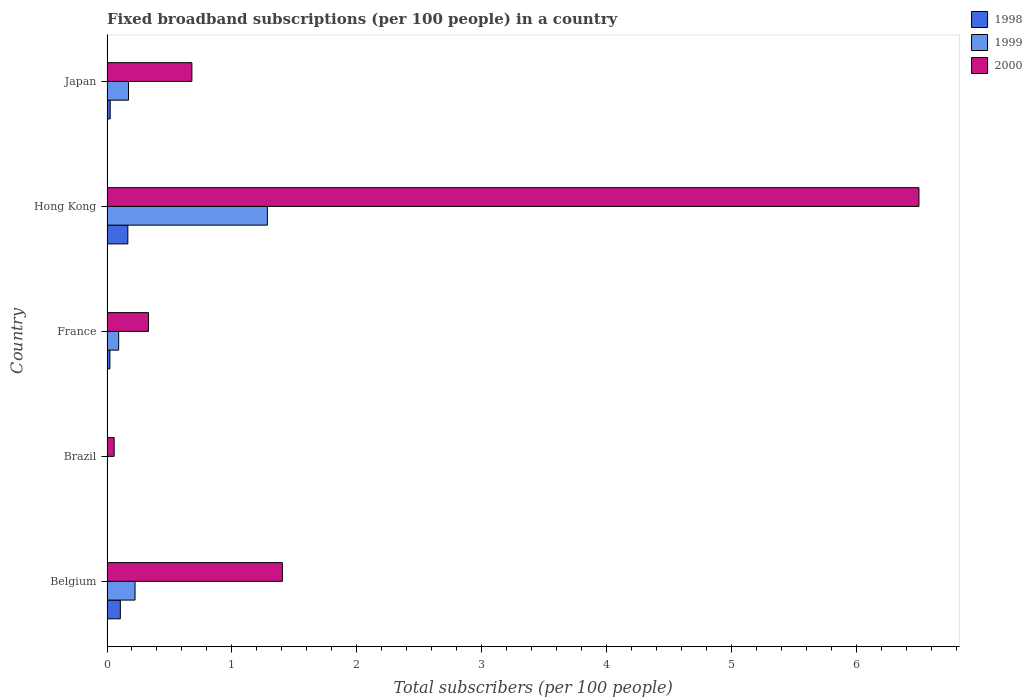How many groups of bars are there?
Provide a succinct answer. 5. How many bars are there on the 1st tick from the top?
Provide a succinct answer. 3. How many bars are there on the 2nd tick from the bottom?
Provide a short and direct response. 3. What is the label of the 5th group of bars from the top?
Provide a succinct answer. Belgium. What is the number of broadband subscriptions in 1998 in France?
Give a very brief answer. 0.02. Across all countries, what is the maximum number of broadband subscriptions in 2000?
Provide a succinct answer. 6.5. Across all countries, what is the minimum number of broadband subscriptions in 1999?
Provide a short and direct response. 0. In which country was the number of broadband subscriptions in 2000 maximum?
Offer a very short reply. Hong Kong. What is the total number of broadband subscriptions in 1998 in the graph?
Offer a terse response. 0.32. What is the difference between the number of broadband subscriptions in 1998 in Belgium and that in France?
Make the answer very short. 0.08. What is the difference between the number of broadband subscriptions in 2000 in Japan and the number of broadband subscriptions in 1999 in France?
Make the answer very short. 0.59. What is the average number of broadband subscriptions in 1999 per country?
Provide a succinct answer. 0.36. What is the difference between the number of broadband subscriptions in 2000 and number of broadband subscriptions in 1999 in Hong Kong?
Provide a succinct answer. 5.22. What is the ratio of the number of broadband subscriptions in 1998 in Belgium to that in France?
Your response must be concise. 4.65. Is the number of broadband subscriptions in 1998 in Belgium less than that in Brazil?
Your answer should be very brief. No. What is the difference between the highest and the second highest number of broadband subscriptions in 1999?
Your answer should be compact. 1.06. What is the difference between the highest and the lowest number of broadband subscriptions in 2000?
Your answer should be compact. 6.44. What does the 1st bar from the top in Belgium represents?
Give a very brief answer. 2000. Are all the bars in the graph horizontal?
Provide a short and direct response. Yes. How many countries are there in the graph?
Offer a very short reply. 5. Are the values on the major ticks of X-axis written in scientific E-notation?
Offer a terse response. No. How are the legend labels stacked?
Give a very brief answer. Vertical. What is the title of the graph?
Your answer should be very brief. Fixed broadband subscriptions (per 100 people) in a country. What is the label or title of the X-axis?
Your answer should be very brief. Total subscribers (per 100 people). What is the label or title of the Y-axis?
Your response must be concise. Country. What is the Total subscribers (per 100 people) in 1998 in Belgium?
Your answer should be compact. 0.11. What is the Total subscribers (per 100 people) in 1999 in Belgium?
Provide a succinct answer. 0.22. What is the Total subscribers (per 100 people) in 2000 in Belgium?
Keep it short and to the point. 1.4. What is the Total subscribers (per 100 people) of 1998 in Brazil?
Give a very brief answer. 0. What is the Total subscribers (per 100 people) in 1999 in Brazil?
Offer a very short reply. 0. What is the Total subscribers (per 100 people) of 2000 in Brazil?
Offer a very short reply. 0.06. What is the Total subscribers (per 100 people) of 1998 in France?
Offer a very short reply. 0.02. What is the Total subscribers (per 100 people) in 1999 in France?
Provide a short and direct response. 0.09. What is the Total subscribers (per 100 people) in 2000 in France?
Keep it short and to the point. 0.33. What is the Total subscribers (per 100 people) in 1998 in Hong Kong?
Your answer should be very brief. 0.17. What is the Total subscribers (per 100 people) in 1999 in Hong Kong?
Your response must be concise. 1.28. What is the Total subscribers (per 100 people) of 2000 in Hong Kong?
Your response must be concise. 6.5. What is the Total subscribers (per 100 people) in 1998 in Japan?
Provide a succinct answer. 0.03. What is the Total subscribers (per 100 people) of 1999 in Japan?
Ensure brevity in your answer.  0.17. What is the Total subscribers (per 100 people) of 2000 in Japan?
Offer a terse response. 0.68. Across all countries, what is the maximum Total subscribers (per 100 people) of 1998?
Your answer should be compact. 0.17. Across all countries, what is the maximum Total subscribers (per 100 people) of 1999?
Provide a short and direct response. 1.28. Across all countries, what is the maximum Total subscribers (per 100 people) in 2000?
Your response must be concise. 6.5. Across all countries, what is the minimum Total subscribers (per 100 people) in 1998?
Offer a terse response. 0. Across all countries, what is the minimum Total subscribers (per 100 people) of 1999?
Provide a short and direct response. 0. Across all countries, what is the minimum Total subscribers (per 100 people) of 2000?
Your answer should be compact. 0.06. What is the total Total subscribers (per 100 people) of 1998 in the graph?
Give a very brief answer. 0.32. What is the total Total subscribers (per 100 people) in 1999 in the graph?
Offer a terse response. 1.78. What is the total Total subscribers (per 100 people) in 2000 in the graph?
Offer a very short reply. 8.98. What is the difference between the Total subscribers (per 100 people) in 1998 in Belgium and that in Brazil?
Offer a very short reply. 0.11. What is the difference between the Total subscribers (per 100 people) in 1999 in Belgium and that in Brazil?
Provide a succinct answer. 0.22. What is the difference between the Total subscribers (per 100 people) of 2000 in Belgium and that in Brazil?
Offer a very short reply. 1.35. What is the difference between the Total subscribers (per 100 people) of 1998 in Belgium and that in France?
Your answer should be very brief. 0.08. What is the difference between the Total subscribers (per 100 people) of 1999 in Belgium and that in France?
Give a very brief answer. 0.13. What is the difference between the Total subscribers (per 100 people) of 2000 in Belgium and that in France?
Offer a very short reply. 1.07. What is the difference between the Total subscribers (per 100 people) in 1998 in Belgium and that in Hong Kong?
Keep it short and to the point. -0.06. What is the difference between the Total subscribers (per 100 people) in 1999 in Belgium and that in Hong Kong?
Give a very brief answer. -1.06. What is the difference between the Total subscribers (per 100 people) in 2000 in Belgium and that in Hong Kong?
Your answer should be compact. -5.1. What is the difference between the Total subscribers (per 100 people) in 1998 in Belgium and that in Japan?
Make the answer very short. 0.08. What is the difference between the Total subscribers (per 100 people) of 1999 in Belgium and that in Japan?
Give a very brief answer. 0.05. What is the difference between the Total subscribers (per 100 people) in 2000 in Belgium and that in Japan?
Provide a succinct answer. 0.72. What is the difference between the Total subscribers (per 100 people) of 1998 in Brazil and that in France?
Your answer should be very brief. -0.02. What is the difference between the Total subscribers (per 100 people) in 1999 in Brazil and that in France?
Provide a succinct answer. -0.09. What is the difference between the Total subscribers (per 100 people) in 2000 in Brazil and that in France?
Your answer should be compact. -0.27. What is the difference between the Total subscribers (per 100 people) in 1998 in Brazil and that in Hong Kong?
Provide a short and direct response. -0.17. What is the difference between the Total subscribers (per 100 people) in 1999 in Brazil and that in Hong Kong?
Your response must be concise. -1.28. What is the difference between the Total subscribers (per 100 people) of 2000 in Brazil and that in Hong Kong?
Make the answer very short. -6.45. What is the difference between the Total subscribers (per 100 people) in 1998 in Brazil and that in Japan?
Give a very brief answer. -0.03. What is the difference between the Total subscribers (per 100 people) of 1999 in Brazil and that in Japan?
Your answer should be compact. -0.17. What is the difference between the Total subscribers (per 100 people) in 2000 in Brazil and that in Japan?
Your response must be concise. -0.62. What is the difference between the Total subscribers (per 100 people) of 1998 in France and that in Hong Kong?
Give a very brief answer. -0.14. What is the difference between the Total subscribers (per 100 people) of 1999 in France and that in Hong Kong?
Your answer should be very brief. -1.19. What is the difference between the Total subscribers (per 100 people) in 2000 in France and that in Hong Kong?
Keep it short and to the point. -6.17. What is the difference between the Total subscribers (per 100 people) in 1998 in France and that in Japan?
Offer a very short reply. -0. What is the difference between the Total subscribers (per 100 people) in 1999 in France and that in Japan?
Offer a very short reply. -0.08. What is the difference between the Total subscribers (per 100 people) of 2000 in France and that in Japan?
Your response must be concise. -0.35. What is the difference between the Total subscribers (per 100 people) in 1998 in Hong Kong and that in Japan?
Offer a very short reply. 0.14. What is the difference between the Total subscribers (per 100 people) in 1999 in Hong Kong and that in Japan?
Offer a very short reply. 1.11. What is the difference between the Total subscribers (per 100 people) of 2000 in Hong Kong and that in Japan?
Your response must be concise. 5.82. What is the difference between the Total subscribers (per 100 people) of 1998 in Belgium and the Total subscribers (per 100 people) of 1999 in Brazil?
Ensure brevity in your answer.  0.1. What is the difference between the Total subscribers (per 100 people) of 1998 in Belgium and the Total subscribers (per 100 people) of 2000 in Brazil?
Your answer should be compact. 0.05. What is the difference between the Total subscribers (per 100 people) of 1999 in Belgium and the Total subscribers (per 100 people) of 2000 in Brazil?
Your response must be concise. 0.17. What is the difference between the Total subscribers (per 100 people) in 1998 in Belgium and the Total subscribers (per 100 people) in 1999 in France?
Your response must be concise. 0.01. What is the difference between the Total subscribers (per 100 people) of 1998 in Belgium and the Total subscribers (per 100 people) of 2000 in France?
Keep it short and to the point. -0.23. What is the difference between the Total subscribers (per 100 people) of 1999 in Belgium and the Total subscribers (per 100 people) of 2000 in France?
Offer a terse response. -0.11. What is the difference between the Total subscribers (per 100 people) in 1998 in Belgium and the Total subscribers (per 100 people) in 1999 in Hong Kong?
Ensure brevity in your answer.  -1.18. What is the difference between the Total subscribers (per 100 people) in 1998 in Belgium and the Total subscribers (per 100 people) in 2000 in Hong Kong?
Make the answer very short. -6.4. What is the difference between the Total subscribers (per 100 people) in 1999 in Belgium and the Total subscribers (per 100 people) in 2000 in Hong Kong?
Make the answer very short. -6.28. What is the difference between the Total subscribers (per 100 people) in 1998 in Belgium and the Total subscribers (per 100 people) in 1999 in Japan?
Keep it short and to the point. -0.07. What is the difference between the Total subscribers (per 100 people) in 1998 in Belgium and the Total subscribers (per 100 people) in 2000 in Japan?
Your response must be concise. -0.57. What is the difference between the Total subscribers (per 100 people) of 1999 in Belgium and the Total subscribers (per 100 people) of 2000 in Japan?
Offer a terse response. -0.46. What is the difference between the Total subscribers (per 100 people) of 1998 in Brazil and the Total subscribers (per 100 people) of 1999 in France?
Your answer should be compact. -0.09. What is the difference between the Total subscribers (per 100 people) in 1998 in Brazil and the Total subscribers (per 100 people) in 2000 in France?
Make the answer very short. -0.33. What is the difference between the Total subscribers (per 100 people) in 1999 in Brazil and the Total subscribers (per 100 people) in 2000 in France?
Offer a very short reply. -0.33. What is the difference between the Total subscribers (per 100 people) in 1998 in Brazil and the Total subscribers (per 100 people) in 1999 in Hong Kong?
Provide a succinct answer. -1.28. What is the difference between the Total subscribers (per 100 people) in 1998 in Brazil and the Total subscribers (per 100 people) in 2000 in Hong Kong?
Your answer should be very brief. -6.5. What is the difference between the Total subscribers (per 100 people) of 1999 in Brazil and the Total subscribers (per 100 people) of 2000 in Hong Kong?
Give a very brief answer. -6.5. What is the difference between the Total subscribers (per 100 people) in 1998 in Brazil and the Total subscribers (per 100 people) in 1999 in Japan?
Offer a terse response. -0.17. What is the difference between the Total subscribers (per 100 people) in 1998 in Brazil and the Total subscribers (per 100 people) in 2000 in Japan?
Offer a terse response. -0.68. What is the difference between the Total subscribers (per 100 people) of 1999 in Brazil and the Total subscribers (per 100 people) of 2000 in Japan?
Ensure brevity in your answer.  -0.68. What is the difference between the Total subscribers (per 100 people) in 1998 in France and the Total subscribers (per 100 people) in 1999 in Hong Kong?
Make the answer very short. -1.26. What is the difference between the Total subscribers (per 100 people) in 1998 in France and the Total subscribers (per 100 people) in 2000 in Hong Kong?
Provide a succinct answer. -6.48. What is the difference between the Total subscribers (per 100 people) of 1999 in France and the Total subscribers (per 100 people) of 2000 in Hong Kong?
Provide a succinct answer. -6.41. What is the difference between the Total subscribers (per 100 people) in 1998 in France and the Total subscribers (per 100 people) in 1999 in Japan?
Your response must be concise. -0.15. What is the difference between the Total subscribers (per 100 people) in 1998 in France and the Total subscribers (per 100 people) in 2000 in Japan?
Make the answer very short. -0.66. What is the difference between the Total subscribers (per 100 people) in 1999 in France and the Total subscribers (per 100 people) in 2000 in Japan?
Offer a terse response. -0.59. What is the difference between the Total subscribers (per 100 people) of 1998 in Hong Kong and the Total subscribers (per 100 people) of 1999 in Japan?
Your answer should be compact. -0.01. What is the difference between the Total subscribers (per 100 people) in 1998 in Hong Kong and the Total subscribers (per 100 people) in 2000 in Japan?
Keep it short and to the point. -0.51. What is the difference between the Total subscribers (per 100 people) in 1999 in Hong Kong and the Total subscribers (per 100 people) in 2000 in Japan?
Keep it short and to the point. 0.6. What is the average Total subscribers (per 100 people) of 1998 per country?
Provide a short and direct response. 0.06. What is the average Total subscribers (per 100 people) of 1999 per country?
Keep it short and to the point. 0.36. What is the average Total subscribers (per 100 people) of 2000 per country?
Give a very brief answer. 1.8. What is the difference between the Total subscribers (per 100 people) in 1998 and Total subscribers (per 100 people) in 1999 in Belgium?
Ensure brevity in your answer.  -0.12. What is the difference between the Total subscribers (per 100 people) in 1998 and Total subscribers (per 100 people) in 2000 in Belgium?
Your answer should be very brief. -1.3. What is the difference between the Total subscribers (per 100 people) in 1999 and Total subscribers (per 100 people) in 2000 in Belgium?
Your answer should be very brief. -1.18. What is the difference between the Total subscribers (per 100 people) of 1998 and Total subscribers (per 100 people) of 1999 in Brazil?
Provide a short and direct response. -0. What is the difference between the Total subscribers (per 100 people) of 1998 and Total subscribers (per 100 people) of 2000 in Brazil?
Ensure brevity in your answer.  -0.06. What is the difference between the Total subscribers (per 100 people) of 1999 and Total subscribers (per 100 people) of 2000 in Brazil?
Provide a short and direct response. -0.05. What is the difference between the Total subscribers (per 100 people) in 1998 and Total subscribers (per 100 people) in 1999 in France?
Your answer should be compact. -0.07. What is the difference between the Total subscribers (per 100 people) of 1998 and Total subscribers (per 100 people) of 2000 in France?
Offer a very short reply. -0.31. What is the difference between the Total subscribers (per 100 people) in 1999 and Total subscribers (per 100 people) in 2000 in France?
Keep it short and to the point. -0.24. What is the difference between the Total subscribers (per 100 people) of 1998 and Total subscribers (per 100 people) of 1999 in Hong Kong?
Provide a succinct answer. -1.12. What is the difference between the Total subscribers (per 100 people) of 1998 and Total subscribers (per 100 people) of 2000 in Hong Kong?
Offer a very short reply. -6.34. What is the difference between the Total subscribers (per 100 people) of 1999 and Total subscribers (per 100 people) of 2000 in Hong Kong?
Give a very brief answer. -5.22. What is the difference between the Total subscribers (per 100 people) of 1998 and Total subscribers (per 100 people) of 1999 in Japan?
Offer a terse response. -0.15. What is the difference between the Total subscribers (per 100 people) in 1998 and Total subscribers (per 100 people) in 2000 in Japan?
Your answer should be very brief. -0.65. What is the difference between the Total subscribers (per 100 people) in 1999 and Total subscribers (per 100 people) in 2000 in Japan?
Ensure brevity in your answer.  -0.51. What is the ratio of the Total subscribers (per 100 people) of 1998 in Belgium to that in Brazil?
Make the answer very short. 181.1. What is the ratio of the Total subscribers (per 100 people) of 1999 in Belgium to that in Brazil?
Offer a terse response. 55.18. What is the ratio of the Total subscribers (per 100 people) in 2000 in Belgium to that in Brazil?
Provide a succinct answer. 24.51. What is the ratio of the Total subscribers (per 100 people) in 1998 in Belgium to that in France?
Offer a very short reply. 4.65. What is the ratio of the Total subscribers (per 100 people) of 1999 in Belgium to that in France?
Make the answer very short. 2.4. What is the ratio of the Total subscribers (per 100 people) in 2000 in Belgium to that in France?
Offer a terse response. 4.23. What is the ratio of the Total subscribers (per 100 people) in 1998 in Belgium to that in Hong Kong?
Your response must be concise. 0.64. What is the ratio of the Total subscribers (per 100 people) of 1999 in Belgium to that in Hong Kong?
Give a very brief answer. 0.17. What is the ratio of the Total subscribers (per 100 people) of 2000 in Belgium to that in Hong Kong?
Offer a terse response. 0.22. What is the ratio of the Total subscribers (per 100 people) of 1998 in Belgium to that in Japan?
Your answer should be very brief. 4.18. What is the ratio of the Total subscribers (per 100 people) in 1999 in Belgium to that in Japan?
Ensure brevity in your answer.  1.3. What is the ratio of the Total subscribers (per 100 people) of 2000 in Belgium to that in Japan?
Keep it short and to the point. 2.07. What is the ratio of the Total subscribers (per 100 people) of 1998 in Brazil to that in France?
Offer a very short reply. 0.03. What is the ratio of the Total subscribers (per 100 people) in 1999 in Brazil to that in France?
Make the answer very short. 0.04. What is the ratio of the Total subscribers (per 100 people) in 2000 in Brazil to that in France?
Provide a succinct answer. 0.17. What is the ratio of the Total subscribers (per 100 people) in 1998 in Brazil to that in Hong Kong?
Provide a short and direct response. 0. What is the ratio of the Total subscribers (per 100 people) of 1999 in Brazil to that in Hong Kong?
Your answer should be very brief. 0. What is the ratio of the Total subscribers (per 100 people) in 2000 in Brazil to that in Hong Kong?
Offer a terse response. 0.01. What is the ratio of the Total subscribers (per 100 people) of 1998 in Brazil to that in Japan?
Give a very brief answer. 0.02. What is the ratio of the Total subscribers (per 100 people) of 1999 in Brazil to that in Japan?
Give a very brief answer. 0.02. What is the ratio of the Total subscribers (per 100 people) of 2000 in Brazil to that in Japan?
Your answer should be compact. 0.08. What is the ratio of the Total subscribers (per 100 people) in 1998 in France to that in Hong Kong?
Your answer should be compact. 0.14. What is the ratio of the Total subscribers (per 100 people) in 1999 in France to that in Hong Kong?
Your answer should be compact. 0.07. What is the ratio of the Total subscribers (per 100 people) of 2000 in France to that in Hong Kong?
Keep it short and to the point. 0.05. What is the ratio of the Total subscribers (per 100 people) in 1998 in France to that in Japan?
Your response must be concise. 0.9. What is the ratio of the Total subscribers (per 100 people) in 1999 in France to that in Japan?
Provide a short and direct response. 0.54. What is the ratio of the Total subscribers (per 100 people) in 2000 in France to that in Japan?
Give a very brief answer. 0.49. What is the ratio of the Total subscribers (per 100 people) of 1998 in Hong Kong to that in Japan?
Offer a very short reply. 6.53. What is the ratio of the Total subscribers (per 100 people) of 1999 in Hong Kong to that in Japan?
Your answer should be very brief. 7.46. What is the ratio of the Total subscribers (per 100 people) in 2000 in Hong Kong to that in Japan?
Keep it short and to the point. 9.56. What is the difference between the highest and the second highest Total subscribers (per 100 people) in 1999?
Offer a very short reply. 1.06. What is the difference between the highest and the second highest Total subscribers (per 100 people) in 2000?
Provide a short and direct response. 5.1. What is the difference between the highest and the lowest Total subscribers (per 100 people) in 1998?
Your answer should be compact. 0.17. What is the difference between the highest and the lowest Total subscribers (per 100 people) in 1999?
Your answer should be compact. 1.28. What is the difference between the highest and the lowest Total subscribers (per 100 people) in 2000?
Give a very brief answer. 6.45. 